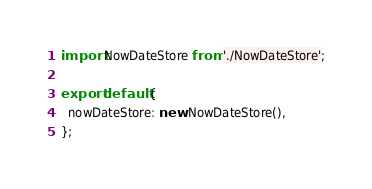Convert code to text. <code><loc_0><loc_0><loc_500><loc_500><_JavaScript_>import NowDateStore from './NowDateStore';

export default {
  nowDateStore: new NowDateStore(),
};
</code> 